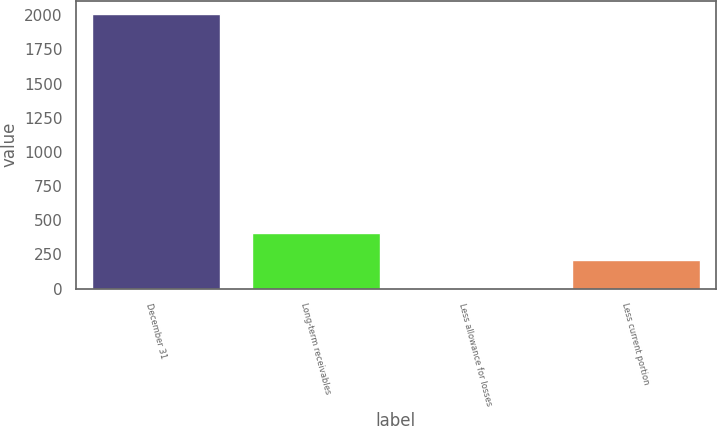<chart> <loc_0><loc_0><loc_500><loc_500><bar_chart><fcel>December 31<fcel>Long-term receivables<fcel>Less allowance for losses<fcel>Less current portion<nl><fcel>2007<fcel>405.4<fcel>5<fcel>205.2<nl></chart> 